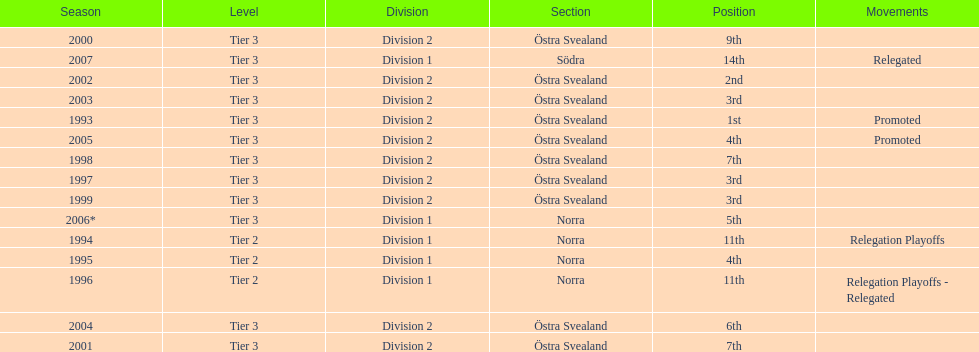How many times is division 2 listed as the division? 10. 